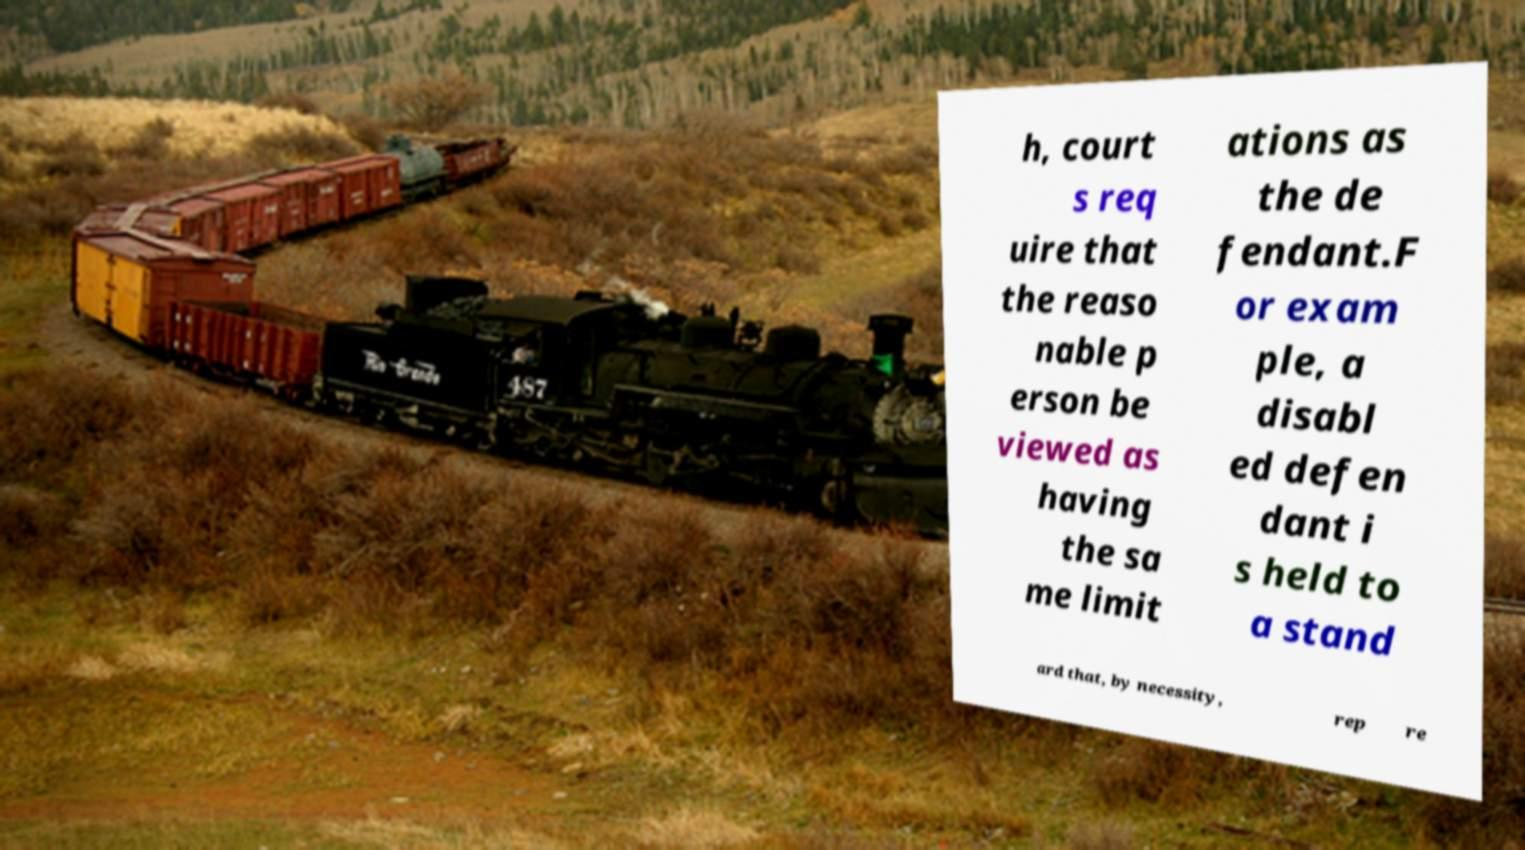Could you extract and type out the text from this image? h, court s req uire that the reaso nable p erson be viewed as having the sa me limit ations as the de fendant.F or exam ple, a disabl ed defen dant i s held to a stand ard that, by necessity, rep re 